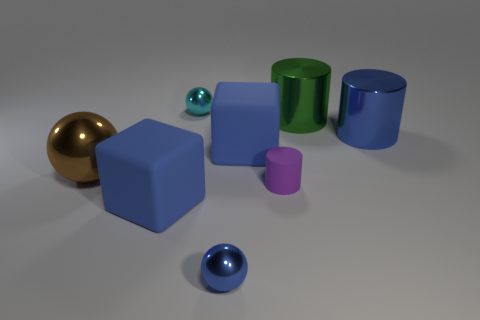Add 1 small cylinders. How many objects exist? 9 Subtract all spheres. How many objects are left? 5 Add 4 small blue shiny spheres. How many small blue shiny spheres exist? 5 Subtract 1 brown balls. How many objects are left? 7 Subtract all large yellow objects. Subtract all cyan metallic objects. How many objects are left? 7 Add 2 small purple things. How many small purple things are left? 3 